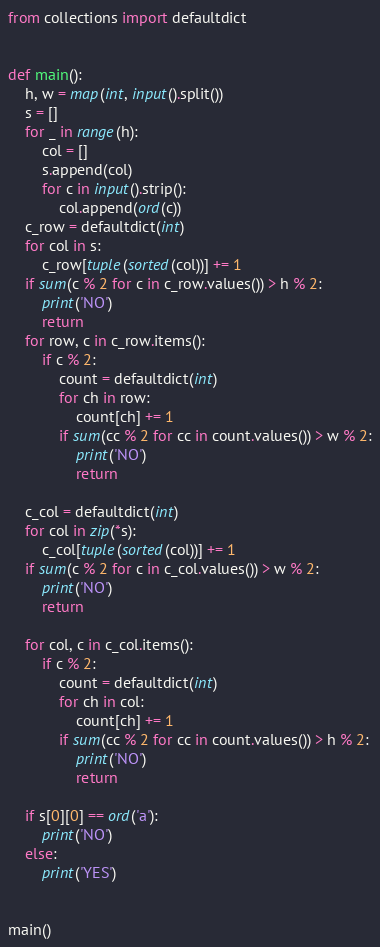Convert code to text. <code><loc_0><loc_0><loc_500><loc_500><_Python_>from collections import defaultdict


def main():
    h, w = map(int, input().split())
    s = []
    for _ in range(h):
        col = []
        s.append(col)
        for c in input().strip():
            col.append(ord(c))
    c_row = defaultdict(int)
    for col in s:
        c_row[tuple(sorted(col))] += 1
    if sum(c % 2 for c in c_row.values()) > h % 2:
        print('NO')
        return
    for row, c in c_row.items():
        if c % 2:
            count = defaultdict(int)
            for ch in row:
                count[ch] += 1
            if sum(cc % 2 for cc in count.values()) > w % 2:
                print('NO')
                return

    c_col = defaultdict(int)
    for col in zip(*s):
        c_col[tuple(sorted(col))] += 1
    if sum(c % 2 for c in c_col.values()) > w % 2:
        print('NO')
        return

    for col, c in c_col.items():
        if c % 2:
            count = defaultdict(int)
            for ch in col:
                count[ch] += 1
            if sum(cc % 2 for cc in count.values()) > h % 2:
                print('NO')
                return

    if s[0][0] == ord('a'):
        print('NO')
    else:
        print('YES')


main()
</code> 